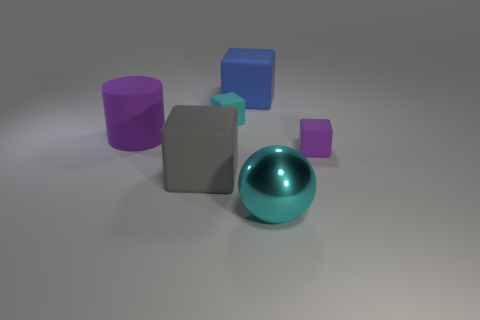Subtract all green cubes. Subtract all green cylinders. How many cubes are left? 4 Add 2 big matte cubes. How many objects exist? 8 Subtract all blocks. How many objects are left? 2 Add 6 blue matte blocks. How many blue matte blocks are left? 7 Add 2 small blue cylinders. How many small blue cylinders exist? 2 Subtract 1 purple blocks. How many objects are left? 5 Subtract all gray cubes. Subtract all big blue things. How many objects are left? 4 